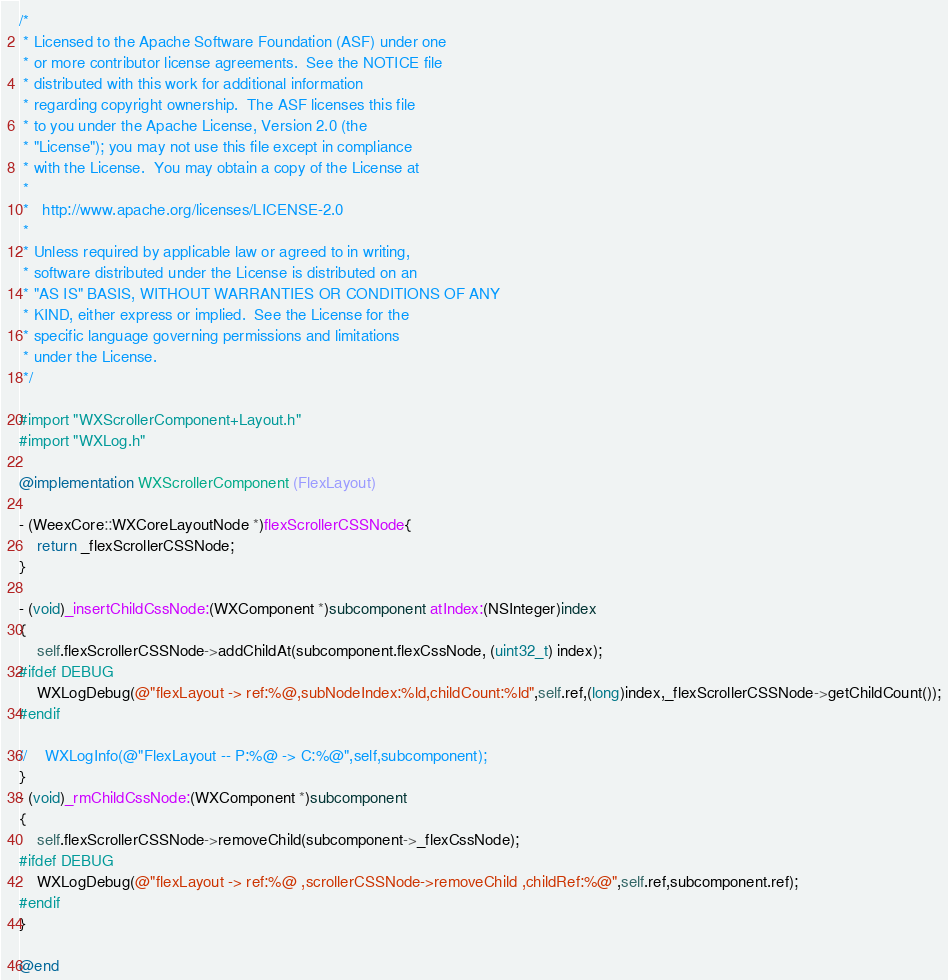<code> <loc_0><loc_0><loc_500><loc_500><_ObjectiveC_>/*
 * Licensed to the Apache Software Foundation (ASF) under one
 * or more contributor license agreements.  See the NOTICE file
 * distributed with this work for additional information
 * regarding copyright ownership.  The ASF licenses this file
 * to you under the Apache License, Version 2.0 (the
 * "License"); you may not use this file except in compliance
 * with the License.  You may obtain a copy of the License at
 *
 *   http://www.apache.org/licenses/LICENSE-2.0
 *
 * Unless required by applicable law or agreed to in writing,
 * software distributed under the License is distributed on an
 * "AS IS" BASIS, WITHOUT WARRANTIES OR CONDITIONS OF ANY
 * KIND, either express or implied.  See the License for the
 * specific language governing permissions and limitations
 * under the License.
 */

#import "WXScrollerComponent+Layout.h"
#import "WXLog.h"

@implementation WXScrollerComponent (FlexLayout)

- (WeexCore::WXCoreLayoutNode *)flexScrollerCSSNode{
    return _flexScrollerCSSNode;
}

- (void)_insertChildCssNode:(WXComponent *)subcomponent atIndex:(NSInteger)index
{
    self.flexScrollerCSSNode->addChildAt(subcomponent.flexCssNode, (uint32_t) index);
#ifdef DEBUG
    WXLogDebug(@"flexLayout -> ref:%@,subNodeIndex:%ld,childCount:%ld",self.ref,(long)index,_flexScrollerCSSNode->getChildCount());
#endif
   
//    WXLogInfo(@"FlexLayout -- P:%@ -> C:%@",self,subcomponent);
}
- (void)_rmChildCssNode:(WXComponent *)subcomponent
{
    self.flexScrollerCSSNode->removeChild(subcomponent->_flexCssNode);
#ifdef DEBUG
    WXLogDebug(@"flexLayout -> ref:%@ ,scrollerCSSNode->removeChild ,childRef:%@",self.ref,subcomponent.ref);
#endif
}

@end
</code> 